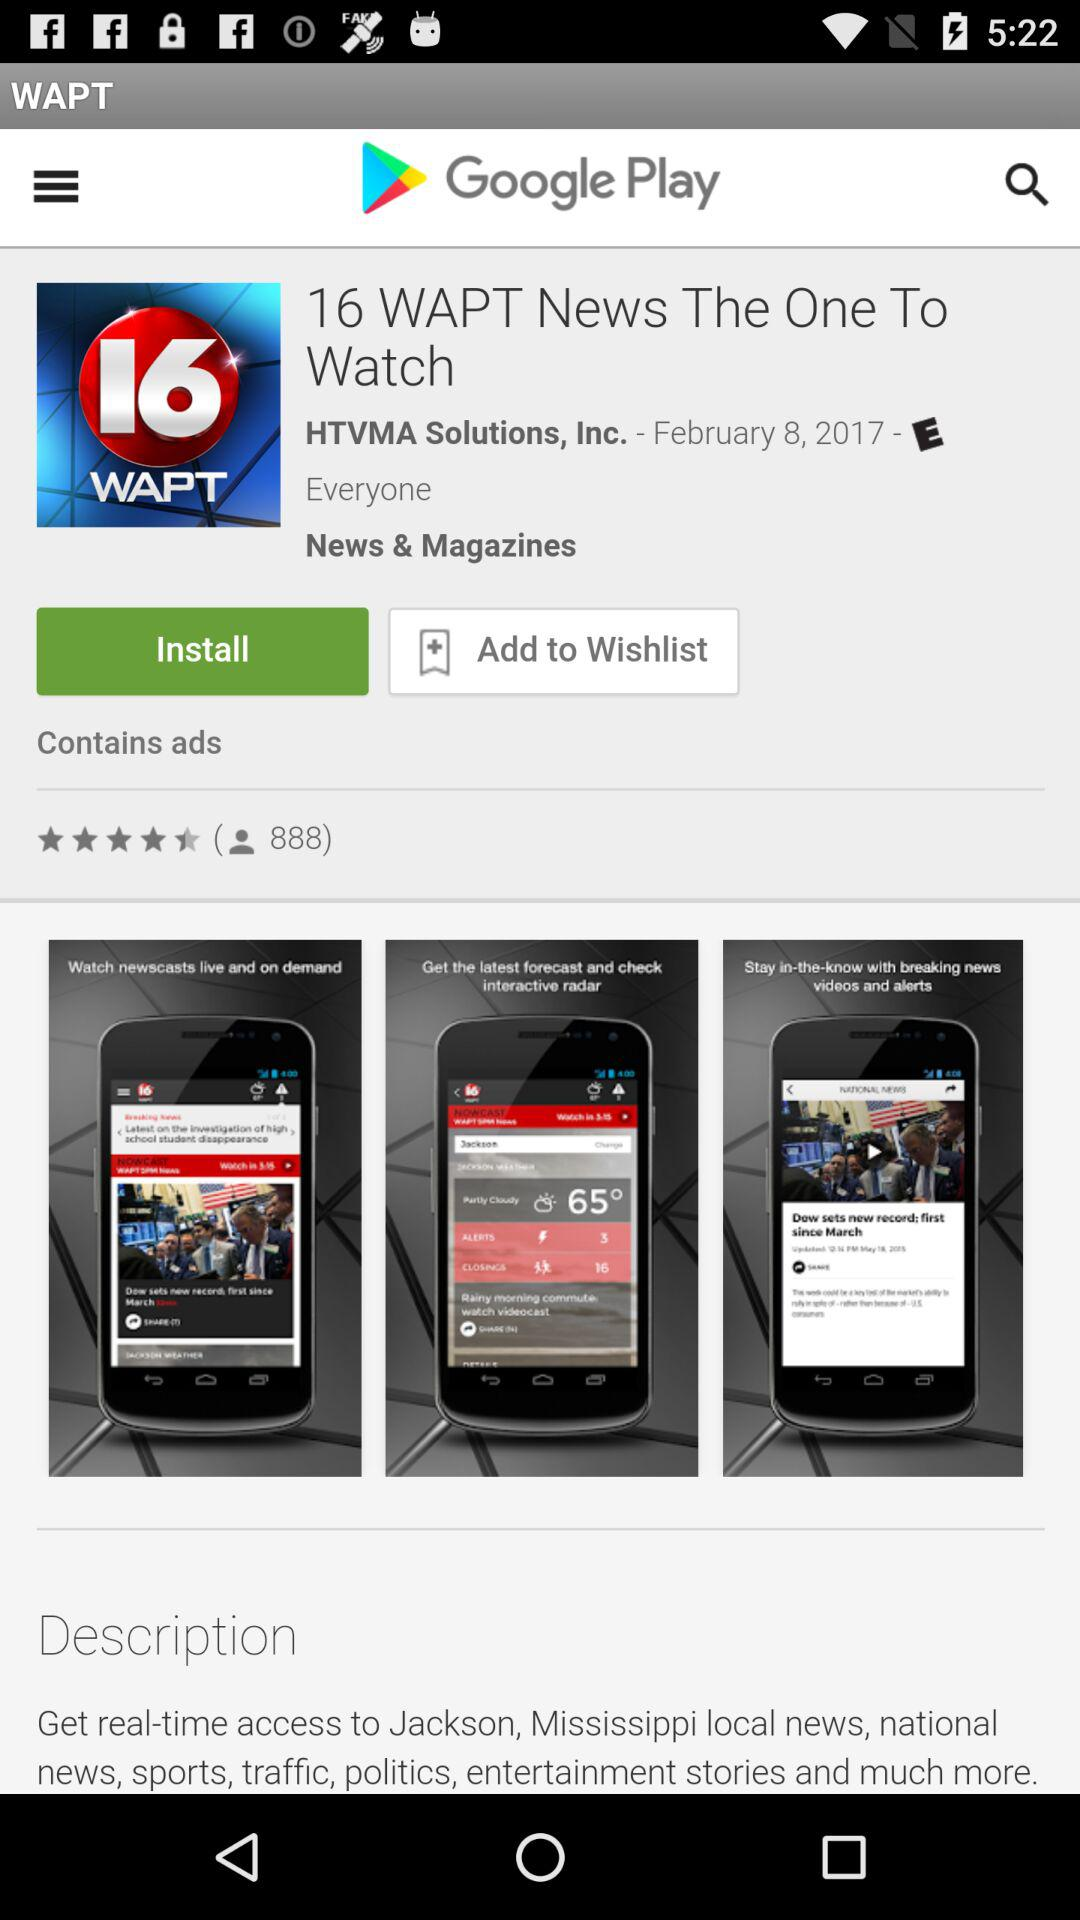Who's the developer of the application? The developer of the application is HTVMA Solutions, Inc. 